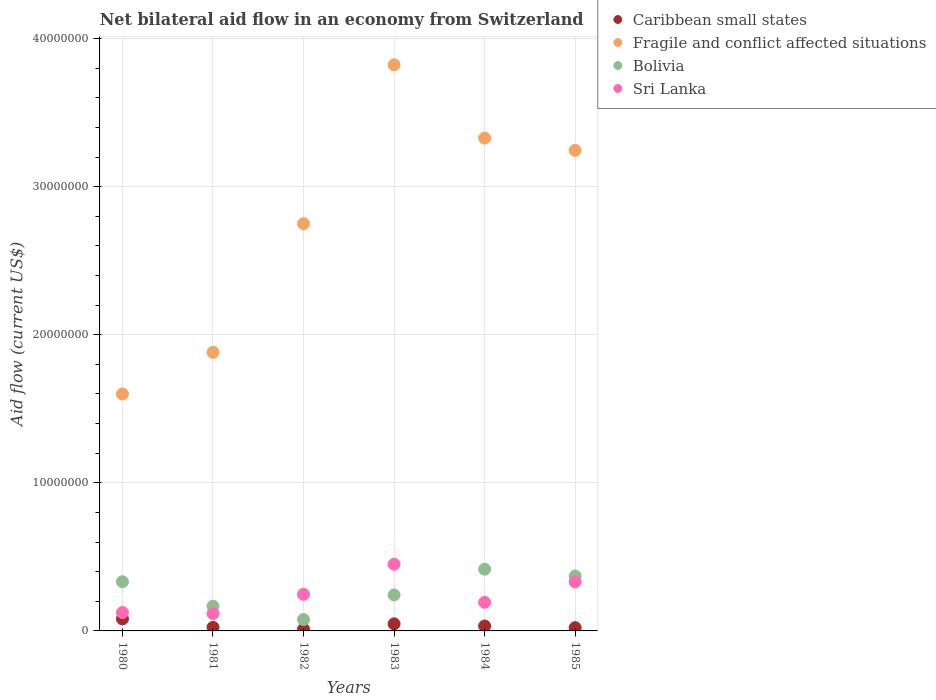How many different coloured dotlines are there?
Provide a succinct answer. 4. Is the number of dotlines equal to the number of legend labels?
Your answer should be very brief. Yes. What is the net bilateral aid flow in Fragile and conflict affected situations in 1985?
Offer a terse response. 3.24e+07. Across all years, what is the maximum net bilateral aid flow in Fragile and conflict affected situations?
Your answer should be compact. 3.82e+07. Across all years, what is the minimum net bilateral aid flow in Fragile and conflict affected situations?
Your answer should be very brief. 1.60e+07. In which year was the net bilateral aid flow in Fragile and conflict affected situations minimum?
Your answer should be compact. 1980. What is the total net bilateral aid flow in Sri Lanka in the graph?
Offer a very short reply. 1.46e+07. What is the difference between the net bilateral aid flow in Sri Lanka in 1981 and that in 1985?
Provide a succinct answer. -2.14e+06. What is the difference between the net bilateral aid flow in Caribbean small states in 1980 and the net bilateral aid flow in Bolivia in 1982?
Make the answer very short. 4.00e+04. What is the average net bilateral aid flow in Fragile and conflict affected situations per year?
Your answer should be very brief. 2.77e+07. In the year 1985, what is the difference between the net bilateral aid flow in Caribbean small states and net bilateral aid flow in Sri Lanka?
Keep it short and to the point. -3.09e+06. What is the ratio of the net bilateral aid flow in Sri Lanka in 1981 to that in 1983?
Your answer should be very brief. 0.26. Is the net bilateral aid flow in Caribbean small states in 1980 less than that in 1981?
Ensure brevity in your answer.  No. Is the difference between the net bilateral aid flow in Caribbean small states in 1982 and 1983 greater than the difference between the net bilateral aid flow in Sri Lanka in 1982 and 1983?
Ensure brevity in your answer.  Yes. What is the difference between the highest and the second highest net bilateral aid flow in Sri Lanka?
Ensure brevity in your answer.  1.19e+06. What is the difference between the highest and the lowest net bilateral aid flow in Sri Lanka?
Make the answer very short. 3.33e+06. In how many years, is the net bilateral aid flow in Caribbean small states greater than the average net bilateral aid flow in Caribbean small states taken over all years?
Give a very brief answer. 2. Is it the case that in every year, the sum of the net bilateral aid flow in Bolivia and net bilateral aid flow in Caribbean small states  is greater than the sum of net bilateral aid flow in Fragile and conflict affected situations and net bilateral aid flow in Sri Lanka?
Your response must be concise. No. Is it the case that in every year, the sum of the net bilateral aid flow in Fragile and conflict affected situations and net bilateral aid flow in Caribbean small states  is greater than the net bilateral aid flow in Sri Lanka?
Your answer should be compact. Yes. Is the net bilateral aid flow in Caribbean small states strictly less than the net bilateral aid flow in Bolivia over the years?
Offer a very short reply. Yes. Are the values on the major ticks of Y-axis written in scientific E-notation?
Your answer should be compact. No. Does the graph contain any zero values?
Your answer should be compact. No. Does the graph contain grids?
Ensure brevity in your answer.  Yes. How are the legend labels stacked?
Offer a terse response. Vertical. What is the title of the graph?
Offer a terse response. Net bilateral aid flow in an economy from Switzerland. What is the label or title of the Y-axis?
Your response must be concise. Aid flow (current US$). What is the Aid flow (current US$) in Caribbean small states in 1980?
Your answer should be very brief. 8.10e+05. What is the Aid flow (current US$) in Fragile and conflict affected situations in 1980?
Offer a very short reply. 1.60e+07. What is the Aid flow (current US$) of Bolivia in 1980?
Your answer should be very brief. 3.32e+06. What is the Aid flow (current US$) in Sri Lanka in 1980?
Give a very brief answer. 1.24e+06. What is the Aid flow (current US$) of Caribbean small states in 1981?
Provide a succinct answer. 2.40e+05. What is the Aid flow (current US$) of Fragile and conflict affected situations in 1981?
Make the answer very short. 1.88e+07. What is the Aid flow (current US$) in Bolivia in 1981?
Your response must be concise. 1.67e+06. What is the Aid flow (current US$) of Sri Lanka in 1981?
Give a very brief answer. 1.17e+06. What is the Aid flow (current US$) in Caribbean small states in 1982?
Offer a terse response. 1.20e+05. What is the Aid flow (current US$) of Fragile and conflict affected situations in 1982?
Keep it short and to the point. 2.75e+07. What is the Aid flow (current US$) of Bolivia in 1982?
Ensure brevity in your answer.  7.70e+05. What is the Aid flow (current US$) in Sri Lanka in 1982?
Provide a short and direct response. 2.47e+06. What is the Aid flow (current US$) in Fragile and conflict affected situations in 1983?
Give a very brief answer. 3.82e+07. What is the Aid flow (current US$) in Bolivia in 1983?
Your response must be concise. 2.43e+06. What is the Aid flow (current US$) in Sri Lanka in 1983?
Keep it short and to the point. 4.50e+06. What is the Aid flow (current US$) of Fragile and conflict affected situations in 1984?
Offer a very short reply. 3.33e+07. What is the Aid flow (current US$) of Bolivia in 1984?
Offer a terse response. 4.17e+06. What is the Aid flow (current US$) of Sri Lanka in 1984?
Offer a very short reply. 1.93e+06. What is the Aid flow (current US$) in Caribbean small states in 1985?
Your response must be concise. 2.20e+05. What is the Aid flow (current US$) in Fragile and conflict affected situations in 1985?
Your response must be concise. 3.24e+07. What is the Aid flow (current US$) of Bolivia in 1985?
Make the answer very short. 3.71e+06. What is the Aid flow (current US$) in Sri Lanka in 1985?
Your answer should be very brief. 3.31e+06. Across all years, what is the maximum Aid flow (current US$) in Caribbean small states?
Your response must be concise. 8.10e+05. Across all years, what is the maximum Aid flow (current US$) of Fragile and conflict affected situations?
Provide a short and direct response. 3.82e+07. Across all years, what is the maximum Aid flow (current US$) in Bolivia?
Provide a short and direct response. 4.17e+06. Across all years, what is the maximum Aid flow (current US$) in Sri Lanka?
Provide a short and direct response. 4.50e+06. Across all years, what is the minimum Aid flow (current US$) of Caribbean small states?
Give a very brief answer. 1.20e+05. Across all years, what is the minimum Aid flow (current US$) of Fragile and conflict affected situations?
Keep it short and to the point. 1.60e+07. Across all years, what is the minimum Aid flow (current US$) in Bolivia?
Your response must be concise. 7.70e+05. Across all years, what is the minimum Aid flow (current US$) of Sri Lanka?
Provide a short and direct response. 1.17e+06. What is the total Aid flow (current US$) in Caribbean small states in the graph?
Give a very brief answer. 2.20e+06. What is the total Aid flow (current US$) of Fragile and conflict affected situations in the graph?
Ensure brevity in your answer.  1.66e+08. What is the total Aid flow (current US$) of Bolivia in the graph?
Your answer should be very brief. 1.61e+07. What is the total Aid flow (current US$) in Sri Lanka in the graph?
Your answer should be very brief. 1.46e+07. What is the difference between the Aid flow (current US$) in Caribbean small states in 1980 and that in 1981?
Offer a terse response. 5.70e+05. What is the difference between the Aid flow (current US$) of Fragile and conflict affected situations in 1980 and that in 1981?
Your response must be concise. -2.81e+06. What is the difference between the Aid flow (current US$) of Bolivia in 1980 and that in 1981?
Offer a terse response. 1.65e+06. What is the difference between the Aid flow (current US$) in Caribbean small states in 1980 and that in 1982?
Ensure brevity in your answer.  6.90e+05. What is the difference between the Aid flow (current US$) of Fragile and conflict affected situations in 1980 and that in 1982?
Make the answer very short. -1.15e+07. What is the difference between the Aid flow (current US$) in Bolivia in 1980 and that in 1982?
Keep it short and to the point. 2.55e+06. What is the difference between the Aid flow (current US$) in Sri Lanka in 1980 and that in 1982?
Provide a short and direct response. -1.23e+06. What is the difference between the Aid flow (current US$) in Caribbean small states in 1980 and that in 1983?
Your response must be concise. 3.30e+05. What is the difference between the Aid flow (current US$) of Fragile and conflict affected situations in 1980 and that in 1983?
Provide a short and direct response. -2.22e+07. What is the difference between the Aid flow (current US$) in Bolivia in 1980 and that in 1983?
Offer a terse response. 8.90e+05. What is the difference between the Aid flow (current US$) in Sri Lanka in 1980 and that in 1983?
Provide a short and direct response. -3.26e+06. What is the difference between the Aid flow (current US$) of Caribbean small states in 1980 and that in 1984?
Your response must be concise. 4.80e+05. What is the difference between the Aid flow (current US$) in Fragile and conflict affected situations in 1980 and that in 1984?
Your answer should be compact. -1.73e+07. What is the difference between the Aid flow (current US$) of Bolivia in 1980 and that in 1984?
Make the answer very short. -8.50e+05. What is the difference between the Aid flow (current US$) in Sri Lanka in 1980 and that in 1984?
Ensure brevity in your answer.  -6.90e+05. What is the difference between the Aid flow (current US$) of Caribbean small states in 1980 and that in 1985?
Provide a succinct answer. 5.90e+05. What is the difference between the Aid flow (current US$) of Fragile and conflict affected situations in 1980 and that in 1985?
Offer a terse response. -1.64e+07. What is the difference between the Aid flow (current US$) in Bolivia in 1980 and that in 1985?
Keep it short and to the point. -3.90e+05. What is the difference between the Aid flow (current US$) of Sri Lanka in 1980 and that in 1985?
Provide a short and direct response. -2.07e+06. What is the difference between the Aid flow (current US$) of Caribbean small states in 1981 and that in 1982?
Provide a short and direct response. 1.20e+05. What is the difference between the Aid flow (current US$) in Fragile and conflict affected situations in 1981 and that in 1982?
Ensure brevity in your answer.  -8.69e+06. What is the difference between the Aid flow (current US$) in Sri Lanka in 1981 and that in 1982?
Make the answer very short. -1.30e+06. What is the difference between the Aid flow (current US$) of Caribbean small states in 1981 and that in 1983?
Your response must be concise. -2.40e+05. What is the difference between the Aid flow (current US$) in Fragile and conflict affected situations in 1981 and that in 1983?
Provide a short and direct response. -1.94e+07. What is the difference between the Aid flow (current US$) in Bolivia in 1981 and that in 1983?
Your answer should be compact. -7.60e+05. What is the difference between the Aid flow (current US$) of Sri Lanka in 1981 and that in 1983?
Your response must be concise. -3.33e+06. What is the difference between the Aid flow (current US$) of Fragile and conflict affected situations in 1981 and that in 1984?
Ensure brevity in your answer.  -1.45e+07. What is the difference between the Aid flow (current US$) of Bolivia in 1981 and that in 1984?
Offer a terse response. -2.50e+06. What is the difference between the Aid flow (current US$) of Sri Lanka in 1981 and that in 1984?
Offer a very short reply. -7.60e+05. What is the difference between the Aid flow (current US$) of Fragile and conflict affected situations in 1981 and that in 1985?
Provide a succinct answer. -1.36e+07. What is the difference between the Aid flow (current US$) of Bolivia in 1981 and that in 1985?
Provide a succinct answer. -2.04e+06. What is the difference between the Aid flow (current US$) in Sri Lanka in 1981 and that in 1985?
Ensure brevity in your answer.  -2.14e+06. What is the difference between the Aid flow (current US$) in Caribbean small states in 1982 and that in 1983?
Your response must be concise. -3.60e+05. What is the difference between the Aid flow (current US$) in Fragile and conflict affected situations in 1982 and that in 1983?
Ensure brevity in your answer.  -1.07e+07. What is the difference between the Aid flow (current US$) in Bolivia in 1982 and that in 1983?
Your answer should be compact. -1.66e+06. What is the difference between the Aid flow (current US$) in Sri Lanka in 1982 and that in 1983?
Your answer should be very brief. -2.03e+06. What is the difference between the Aid flow (current US$) in Fragile and conflict affected situations in 1982 and that in 1984?
Provide a short and direct response. -5.78e+06. What is the difference between the Aid flow (current US$) of Bolivia in 1982 and that in 1984?
Make the answer very short. -3.40e+06. What is the difference between the Aid flow (current US$) in Sri Lanka in 1982 and that in 1984?
Make the answer very short. 5.40e+05. What is the difference between the Aid flow (current US$) in Caribbean small states in 1982 and that in 1985?
Make the answer very short. -1.00e+05. What is the difference between the Aid flow (current US$) in Fragile and conflict affected situations in 1982 and that in 1985?
Give a very brief answer. -4.95e+06. What is the difference between the Aid flow (current US$) of Bolivia in 1982 and that in 1985?
Offer a very short reply. -2.94e+06. What is the difference between the Aid flow (current US$) in Sri Lanka in 1982 and that in 1985?
Keep it short and to the point. -8.40e+05. What is the difference between the Aid flow (current US$) of Fragile and conflict affected situations in 1983 and that in 1984?
Offer a terse response. 4.95e+06. What is the difference between the Aid flow (current US$) of Bolivia in 1983 and that in 1984?
Keep it short and to the point. -1.74e+06. What is the difference between the Aid flow (current US$) in Sri Lanka in 1983 and that in 1984?
Provide a succinct answer. 2.57e+06. What is the difference between the Aid flow (current US$) in Fragile and conflict affected situations in 1983 and that in 1985?
Offer a terse response. 5.78e+06. What is the difference between the Aid flow (current US$) in Bolivia in 1983 and that in 1985?
Ensure brevity in your answer.  -1.28e+06. What is the difference between the Aid flow (current US$) of Sri Lanka in 1983 and that in 1985?
Your answer should be very brief. 1.19e+06. What is the difference between the Aid flow (current US$) in Caribbean small states in 1984 and that in 1985?
Ensure brevity in your answer.  1.10e+05. What is the difference between the Aid flow (current US$) of Fragile and conflict affected situations in 1984 and that in 1985?
Your response must be concise. 8.30e+05. What is the difference between the Aid flow (current US$) of Sri Lanka in 1984 and that in 1985?
Give a very brief answer. -1.38e+06. What is the difference between the Aid flow (current US$) of Caribbean small states in 1980 and the Aid flow (current US$) of Fragile and conflict affected situations in 1981?
Provide a succinct answer. -1.80e+07. What is the difference between the Aid flow (current US$) in Caribbean small states in 1980 and the Aid flow (current US$) in Bolivia in 1981?
Give a very brief answer. -8.60e+05. What is the difference between the Aid flow (current US$) in Caribbean small states in 1980 and the Aid flow (current US$) in Sri Lanka in 1981?
Offer a terse response. -3.60e+05. What is the difference between the Aid flow (current US$) of Fragile and conflict affected situations in 1980 and the Aid flow (current US$) of Bolivia in 1981?
Your answer should be very brief. 1.43e+07. What is the difference between the Aid flow (current US$) of Fragile and conflict affected situations in 1980 and the Aid flow (current US$) of Sri Lanka in 1981?
Provide a short and direct response. 1.48e+07. What is the difference between the Aid flow (current US$) in Bolivia in 1980 and the Aid flow (current US$) in Sri Lanka in 1981?
Your answer should be very brief. 2.15e+06. What is the difference between the Aid flow (current US$) in Caribbean small states in 1980 and the Aid flow (current US$) in Fragile and conflict affected situations in 1982?
Your answer should be very brief. -2.67e+07. What is the difference between the Aid flow (current US$) in Caribbean small states in 1980 and the Aid flow (current US$) in Sri Lanka in 1982?
Provide a succinct answer. -1.66e+06. What is the difference between the Aid flow (current US$) in Fragile and conflict affected situations in 1980 and the Aid flow (current US$) in Bolivia in 1982?
Give a very brief answer. 1.52e+07. What is the difference between the Aid flow (current US$) of Fragile and conflict affected situations in 1980 and the Aid flow (current US$) of Sri Lanka in 1982?
Offer a very short reply. 1.35e+07. What is the difference between the Aid flow (current US$) of Bolivia in 1980 and the Aid flow (current US$) of Sri Lanka in 1982?
Your answer should be compact. 8.50e+05. What is the difference between the Aid flow (current US$) in Caribbean small states in 1980 and the Aid flow (current US$) in Fragile and conflict affected situations in 1983?
Your answer should be very brief. -3.74e+07. What is the difference between the Aid flow (current US$) of Caribbean small states in 1980 and the Aid flow (current US$) of Bolivia in 1983?
Give a very brief answer. -1.62e+06. What is the difference between the Aid flow (current US$) in Caribbean small states in 1980 and the Aid flow (current US$) in Sri Lanka in 1983?
Provide a short and direct response. -3.69e+06. What is the difference between the Aid flow (current US$) of Fragile and conflict affected situations in 1980 and the Aid flow (current US$) of Bolivia in 1983?
Make the answer very short. 1.36e+07. What is the difference between the Aid flow (current US$) in Fragile and conflict affected situations in 1980 and the Aid flow (current US$) in Sri Lanka in 1983?
Offer a terse response. 1.15e+07. What is the difference between the Aid flow (current US$) of Bolivia in 1980 and the Aid flow (current US$) of Sri Lanka in 1983?
Offer a terse response. -1.18e+06. What is the difference between the Aid flow (current US$) in Caribbean small states in 1980 and the Aid flow (current US$) in Fragile and conflict affected situations in 1984?
Make the answer very short. -3.25e+07. What is the difference between the Aid flow (current US$) in Caribbean small states in 1980 and the Aid flow (current US$) in Bolivia in 1984?
Your answer should be very brief. -3.36e+06. What is the difference between the Aid flow (current US$) in Caribbean small states in 1980 and the Aid flow (current US$) in Sri Lanka in 1984?
Your answer should be very brief. -1.12e+06. What is the difference between the Aid flow (current US$) in Fragile and conflict affected situations in 1980 and the Aid flow (current US$) in Bolivia in 1984?
Offer a terse response. 1.18e+07. What is the difference between the Aid flow (current US$) of Fragile and conflict affected situations in 1980 and the Aid flow (current US$) of Sri Lanka in 1984?
Your answer should be compact. 1.41e+07. What is the difference between the Aid flow (current US$) in Bolivia in 1980 and the Aid flow (current US$) in Sri Lanka in 1984?
Your answer should be compact. 1.39e+06. What is the difference between the Aid flow (current US$) in Caribbean small states in 1980 and the Aid flow (current US$) in Fragile and conflict affected situations in 1985?
Provide a short and direct response. -3.16e+07. What is the difference between the Aid flow (current US$) of Caribbean small states in 1980 and the Aid flow (current US$) of Bolivia in 1985?
Make the answer very short. -2.90e+06. What is the difference between the Aid flow (current US$) of Caribbean small states in 1980 and the Aid flow (current US$) of Sri Lanka in 1985?
Your answer should be very brief. -2.50e+06. What is the difference between the Aid flow (current US$) in Fragile and conflict affected situations in 1980 and the Aid flow (current US$) in Bolivia in 1985?
Your response must be concise. 1.23e+07. What is the difference between the Aid flow (current US$) in Fragile and conflict affected situations in 1980 and the Aid flow (current US$) in Sri Lanka in 1985?
Your answer should be very brief. 1.27e+07. What is the difference between the Aid flow (current US$) in Bolivia in 1980 and the Aid flow (current US$) in Sri Lanka in 1985?
Make the answer very short. 10000. What is the difference between the Aid flow (current US$) of Caribbean small states in 1981 and the Aid flow (current US$) of Fragile and conflict affected situations in 1982?
Your response must be concise. -2.73e+07. What is the difference between the Aid flow (current US$) of Caribbean small states in 1981 and the Aid flow (current US$) of Bolivia in 1982?
Offer a terse response. -5.30e+05. What is the difference between the Aid flow (current US$) of Caribbean small states in 1981 and the Aid flow (current US$) of Sri Lanka in 1982?
Your answer should be very brief. -2.23e+06. What is the difference between the Aid flow (current US$) of Fragile and conflict affected situations in 1981 and the Aid flow (current US$) of Bolivia in 1982?
Your answer should be compact. 1.80e+07. What is the difference between the Aid flow (current US$) in Fragile and conflict affected situations in 1981 and the Aid flow (current US$) in Sri Lanka in 1982?
Offer a very short reply. 1.63e+07. What is the difference between the Aid flow (current US$) of Bolivia in 1981 and the Aid flow (current US$) of Sri Lanka in 1982?
Provide a short and direct response. -8.00e+05. What is the difference between the Aid flow (current US$) of Caribbean small states in 1981 and the Aid flow (current US$) of Fragile and conflict affected situations in 1983?
Your answer should be compact. -3.80e+07. What is the difference between the Aid flow (current US$) in Caribbean small states in 1981 and the Aid flow (current US$) in Bolivia in 1983?
Ensure brevity in your answer.  -2.19e+06. What is the difference between the Aid flow (current US$) of Caribbean small states in 1981 and the Aid flow (current US$) of Sri Lanka in 1983?
Your answer should be very brief. -4.26e+06. What is the difference between the Aid flow (current US$) of Fragile and conflict affected situations in 1981 and the Aid flow (current US$) of Bolivia in 1983?
Give a very brief answer. 1.64e+07. What is the difference between the Aid flow (current US$) of Fragile and conflict affected situations in 1981 and the Aid flow (current US$) of Sri Lanka in 1983?
Your response must be concise. 1.43e+07. What is the difference between the Aid flow (current US$) in Bolivia in 1981 and the Aid flow (current US$) in Sri Lanka in 1983?
Provide a short and direct response. -2.83e+06. What is the difference between the Aid flow (current US$) in Caribbean small states in 1981 and the Aid flow (current US$) in Fragile and conflict affected situations in 1984?
Keep it short and to the point. -3.30e+07. What is the difference between the Aid flow (current US$) in Caribbean small states in 1981 and the Aid flow (current US$) in Bolivia in 1984?
Your answer should be compact. -3.93e+06. What is the difference between the Aid flow (current US$) of Caribbean small states in 1981 and the Aid flow (current US$) of Sri Lanka in 1984?
Offer a terse response. -1.69e+06. What is the difference between the Aid flow (current US$) of Fragile and conflict affected situations in 1981 and the Aid flow (current US$) of Bolivia in 1984?
Offer a very short reply. 1.46e+07. What is the difference between the Aid flow (current US$) of Fragile and conflict affected situations in 1981 and the Aid flow (current US$) of Sri Lanka in 1984?
Provide a short and direct response. 1.69e+07. What is the difference between the Aid flow (current US$) in Bolivia in 1981 and the Aid flow (current US$) in Sri Lanka in 1984?
Offer a terse response. -2.60e+05. What is the difference between the Aid flow (current US$) of Caribbean small states in 1981 and the Aid flow (current US$) of Fragile and conflict affected situations in 1985?
Provide a short and direct response. -3.22e+07. What is the difference between the Aid flow (current US$) of Caribbean small states in 1981 and the Aid flow (current US$) of Bolivia in 1985?
Make the answer very short. -3.47e+06. What is the difference between the Aid flow (current US$) of Caribbean small states in 1981 and the Aid flow (current US$) of Sri Lanka in 1985?
Offer a very short reply. -3.07e+06. What is the difference between the Aid flow (current US$) in Fragile and conflict affected situations in 1981 and the Aid flow (current US$) in Bolivia in 1985?
Provide a succinct answer. 1.51e+07. What is the difference between the Aid flow (current US$) of Fragile and conflict affected situations in 1981 and the Aid flow (current US$) of Sri Lanka in 1985?
Your answer should be compact. 1.55e+07. What is the difference between the Aid flow (current US$) in Bolivia in 1981 and the Aid flow (current US$) in Sri Lanka in 1985?
Your response must be concise. -1.64e+06. What is the difference between the Aid flow (current US$) in Caribbean small states in 1982 and the Aid flow (current US$) in Fragile and conflict affected situations in 1983?
Your response must be concise. -3.81e+07. What is the difference between the Aid flow (current US$) of Caribbean small states in 1982 and the Aid flow (current US$) of Bolivia in 1983?
Offer a very short reply. -2.31e+06. What is the difference between the Aid flow (current US$) of Caribbean small states in 1982 and the Aid flow (current US$) of Sri Lanka in 1983?
Ensure brevity in your answer.  -4.38e+06. What is the difference between the Aid flow (current US$) in Fragile and conflict affected situations in 1982 and the Aid flow (current US$) in Bolivia in 1983?
Keep it short and to the point. 2.51e+07. What is the difference between the Aid flow (current US$) of Fragile and conflict affected situations in 1982 and the Aid flow (current US$) of Sri Lanka in 1983?
Offer a very short reply. 2.30e+07. What is the difference between the Aid flow (current US$) in Bolivia in 1982 and the Aid flow (current US$) in Sri Lanka in 1983?
Offer a terse response. -3.73e+06. What is the difference between the Aid flow (current US$) in Caribbean small states in 1982 and the Aid flow (current US$) in Fragile and conflict affected situations in 1984?
Provide a succinct answer. -3.32e+07. What is the difference between the Aid flow (current US$) of Caribbean small states in 1982 and the Aid flow (current US$) of Bolivia in 1984?
Offer a terse response. -4.05e+06. What is the difference between the Aid flow (current US$) of Caribbean small states in 1982 and the Aid flow (current US$) of Sri Lanka in 1984?
Your answer should be very brief. -1.81e+06. What is the difference between the Aid flow (current US$) in Fragile and conflict affected situations in 1982 and the Aid flow (current US$) in Bolivia in 1984?
Ensure brevity in your answer.  2.33e+07. What is the difference between the Aid flow (current US$) in Fragile and conflict affected situations in 1982 and the Aid flow (current US$) in Sri Lanka in 1984?
Ensure brevity in your answer.  2.56e+07. What is the difference between the Aid flow (current US$) of Bolivia in 1982 and the Aid flow (current US$) of Sri Lanka in 1984?
Ensure brevity in your answer.  -1.16e+06. What is the difference between the Aid flow (current US$) of Caribbean small states in 1982 and the Aid flow (current US$) of Fragile and conflict affected situations in 1985?
Offer a very short reply. -3.23e+07. What is the difference between the Aid flow (current US$) of Caribbean small states in 1982 and the Aid flow (current US$) of Bolivia in 1985?
Keep it short and to the point. -3.59e+06. What is the difference between the Aid flow (current US$) in Caribbean small states in 1982 and the Aid flow (current US$) in Sri Lanka in 1985?
Ensure brevity in your answer.  -3.19e+06. What is the difference between the Aid flow (current US$) of Fragile and conflict affected situations in 1982 and the Aid flow (current US$) of Bolivia in 1985?
Your answer should be very brief. 2.38e+07. What is the difference between the Aid flow (current US$) in Fragile and conflict affected situations in 1982 and the Aid flow (current US$) in Sri Lanka in 1985?
Make the answer very short. 2.42e+07. What is the difference between the Aid flow (current US$) of Bolivia in 1982 and the Aid flow (current US$) of Sri Lanka in 1985?
Your answer should be compact. -2.54e+06. What is the difference between the Aid flow (current US$) of Caribbean small states in 1983 and the Aid flow (current US$) of Fragile and conflict affected situations in 1984?
Your answer should be very brief. -3.28e+07. What is the difference between the Aid flow (current US$) in Caribbean small states in 1983 and the Aid flow (current US$) in Bolivia in 1984?
Provide a succinct answer. -3.69e+06. What is the difference between the Aid flow (current US$) in Caribbean small states in 1983 and the Aid flow (current US$) in Sri Lanka in 1984?
Your response must be concise. -1.45e+06. What is the difference between the Aid flow (current US$) in Fragile and conflict affected situations in 1983 and the Aid flow (current US$) in Bolivia in 1984?
Provide a short and direct response. 3.41e+07. What is the difference between the Aid flow (current US$) of Fragile and conflict affected situations in 1983 and the Aid flow (current US$) of Sri Lanka in 1984?
Provide a short and direct response. 3.63e+07. What is the difference between the Aid flow (current US$) of Caribbean small states in 1983 and the Aid flow (current US$) of Fragile and conflict affected situations in 1985?
Provide a short and direct response. -3.20e+07. What is the difference between the Aid flow (current US$) of Caribbean small states in 1983 and the Aid flow (current US$) of Bolivia in 1985?
Provide a short and direct response. -3.23e+06. What is the difference between the Aid flow (current US$) in Caribbean small states in 1983 and the Aid flow (current US$) in Sri Lanka in 1985?
Your answer should be compact. -2.83e+06. What is the difference between the Aid flow (current US$) of Fragile and conflict affected situations in 1983 and the Aid flow (current US$) of Bolivia in 1985?
Your answer should be compact. 3.45e+07. What is the difference between the Aid flow (current US$) of Fragile and conflict affected situations in 1983 and the Aid flow (current US$) of Sri Lanka in 1985?
Give a very brief answer. 3.49e+07. What is the difference between the Aid flow (current US$) in Bolivia in 1983 and the Aid flow (current US$) in Sri Lanka in 1985?
Offer a very short reply. -8.80e+05. What is the difference between the Aid flow (current US$) of Caribbean small states in 1984 and the Aid flow (current US$) of Fragile and conflict affected situations in 1985?
Keep it short and to the point. -3.21e+07. What is the difference between the Aid flow (current US$) in Caribbean small states in 1984 and the Aid flow (current US$) in Bolivia in 1985?
Ensure brevity in your answer.  -3.38e+06. What is the difference between the Aid flow (current US$) in Caribbean small states in 1984 and the Aid flow (current US$) in Sri Lanka in 1985?
Your answer should be very brief. -2.98e+06. What is the difference between the Aid flow (current US$) of Fragile and conflict affected situations in 1984 and the Aid flow (current US$) of Bolivia in 1985?
Make the answer very short. 2.96e+07. What is the difference between the Aid flow (current US$) of Fragile and conflict affected situations in 1984 and the Aid flow (current US$) of Sri Lanka in 1985?
Keep it short and to the point. 3.00e+07. What is the difference between the Aid flow (current US$) in Bolivia in 1984 and the Aid flow (current US$) in Sri Lanka in 1985?
Provide a short and direct response. 8.60e+05. What is the average Aid flow (current US$) in Caribbean small states per year?
Ensure brevity in your answer.  3.67e+05. What is the average Aid flow (current US$) of Fragile and conflict affected situations per year?
Your answer should be very brief. 2.77e+07. What is the average Aid flow (current US$) in Bolivia per year?
Provide a succinct answer. 2.68e+06. What is the average Aid flow (current US$) of Sri Lanka per year?
Your answer should be very brief. 2.44e+06. In the year 1980, what is the difference between the Aid flow (current US$) in Caribbean small states and Aid flow (current US$) in Fragile and conflict affected situations?
Your answer should be compact. -1.52e+07. In the year 1980, what is the difference between the Aid flow (current US$) of Caribbean small states and Aid flow (current US$) of Bolivia?
Provide a succinct answer. -2.51e+06. In the year 1980, what is the difference between the Aid flow (current US$) of Caribbean small states and Aid flow (current US$) of Sri Lanka?
Your response must be concise. -4.30e+05. In the year 1980, what is the difference between the Aid flow (current US$) in Fragile and conflict affected situations and Aid flow (current US$) in Bolivia?
Provide a short and direct response. 1.27e+07. In the year 1980, what is the difference between the Aid flow (current US$) of Fragile and conflict affected situations and Aid flow (current US$) of Sri Lanka?
Provide a succinct answer. 1.48e+07. In the year 1980, what is the difference between the Aid flow (current US$) of Bolivia and Aid flow (current US$) of Sri Lanka?
Make the answer very short. 2.08e+06. In the year 1981, what is the difference between the Aid flow (current US$) in Caribbean small states and Aid flow (current US$) in Fragile and conflict affected situations?
Your answer should be compact. -1.86e+07. In the year 1981, what is the difference between the Aid flow (current US$) in Caribbean small states and Aid flow (current US$) in Bolivia?
Your answer should be compact. -1.43e+06. In the year 1981, what is the difference between the Aid flow (current US$) of Caribbean small states and Aid flow (current US$) of Sri Lanka?
Keep it short and to the point. -9.30e+05. In the year 1981, what is the difference between the Aid flow (current US$) of Fragile and conflict affected situations and Aid flow (current US$) of Bolivia?
Your answer should be compact. 1.71e+07. In the year 1981, what is the difference between the Aid flow (current US$) of Fragile and conflict affected situations and Aid flow (current US$) of Sri Lanka?
Your answer should be very brief. 1.76e+07. In the year 1981, what is the difference between the Aid flow (current US$) in Bolivia and Aid flow (current US$) in Sri Lanka?
Ensure brevity in your answer.  5.00e+05. In the year 1982, what is the difference between the Aid flow (current US$) in Caribbean small states and Aid flow (current US$) in Fragile and conflict affected situations?
Your answer should be very brief. -2.74e+07. In the year 1982, what is the difference between the Aid flow (current US$) of Caribbean small states and Aid flow (current US$) of Bolivia?
Make the answer very short. -6.50e+05. In the year 1982, what is the difference between the Aid flow (current US$) in Caribbean small states and Aid flow (current US$) in Sri Lanka?
Ensure brevity in your answer.  -2.35e+06. In the year 1982, what is the difference between the Aid flow (current US$) of Fragile and conflict affected situations and Aid flow (current US$) of Bolivia?
Your response must be concise. 2.67e+07. In the year 1982, what is the difference between the Aid flow (current US$) in Fragile and conflict affected situations and Aid flow (current US$) in Sri Lanka?
Offer a terse response. 2.50e+07. In the year 1982, what is the difference between the Aid flow (current US$) in Bolivia and Aid flow (current US$) in Sri Lanka?
Your response must be concise. -1.70e+06. In the year 1983, what is the difference between the Aid flow (current US$) of Caribbean small states and Aid flow (current US$) of Fragile and conflict affected situations?
Give a very brief answer. -3.78e+07. In the year 1983, what is the difference between the Aid flow (current US$) in Caribbean small states and Aid flow (current US$) in Bolivia?
Offer a terse response. -1.95e+06. In the year 1983, what is the difference between the Aid flow (current US$) in Caribbean small states and Aid flow (current US$) in Sri Lanka?
Offer a very short reply. -4.02e+06. In the year 1983, what is the difference between the Aid flow (current US$) of Fragile and conflict affected situations and Aid flow (current US$) of Bolivia?
Ensure brevity in your answer.  3.58e+07. In the year 1983, what is the difference between the Aid flow (current US$) of Fragile and conflict affected situations and Aid flow (current US$) of Sri Lanka?
Provide a short and direct response. 3.37e+07. In the year 1983, what is the difference between the Aid flow (current US$) of Bolivia and Aid flow (current US$) of Sri Lanka?
Give a very brief answer. -2.07e+06. In the year 1984, what is the difference between the Aid flow (current US$) in Caribbean small states and Aid flow (current US$) in Fragile and conflict affected situations?
Offer a very short reply. -3.30e+07. In the year 1984, what is the difference between the Aid flow (current US$) in Caribbean small states and Aid flow (current US$) in Bolivia?
Give a very brief answer. -3.84e+06. In the year 1984, what is the difference between the Aid flow (current US$) in Caribbean small states and Aid flow (current US$) in Sri Lanka?
Your answer should be very brief. -1.60e+06. In the year 1984, what is the difference between the Aid flow (current US$) in Fragile and conflict affected situations and Aid flow (current US$) in Bolivia?
Give a very brief answer. 2.91e+07. In the year 1984, what is the difference between the Aid flow (current US$) of Fragile and conflict affected situations and Aid flow (current US$) of Sri Lanka?
Provide a succinct answer. 3.14e+07. In the year 1984, what is the difference between the Aid flow (current US$) of Bolivia and Aid flow (current US$) of Sri Lanka?
Offer a very short reply. 2.24e+06. In the year 1985, what is the difference between the Aid flow (current US$) of Caribbean small states and Aid flow (current US$) of Fragile and conflict affected situations?
Provide a short and direct response. -3.22e+07. In the year 1985, what is the difference between the Aid flow (current US$) of Caribbean small states and Aid flow (current US$) of Bolivia?
Offer a terse response. -3.49e+06. In the year 1985, what is the difference between the Aid flow (current US$) of Caribbean small states and Aid flow (current US$) of Sri Lanka?
Provide a succinct answer. -3.09e+06. In the year 1985, what is the difference between the Aid flow (current US$) in Fragile and conflict affected situations and Aid flow (current US$) in Bolivia?
Your response must be concise. 2.87e+07. In the year 1985, what is the difference between the Aid flow (current US$) in Fragile and conflict affected situations and Aid flow (current US$) in Sri Lanka?
Provide a succinct answer. 2.91e+07. What is the ratio of the Aid flow (current US$) of Caribbean small states in 1980 to that in 1981?
Provide a succinct answer. 3.38. What is the ratio of the Aid flow (current US$) of Fragile and conflict affected situations in 1980 to that in 1981?
Make the answer very short. 0.85. What is the ratio of the Aid flow (current US$) of Bolivia in 1980 to that in 1981?
Offer a very short reply. 1.99. What is the ratio of the Aid flow (current US$) in Sri Lanka in 1980 to that in 1981?
Your answer should be very brief. 1.06. What is the ratio of the Aid flow (current US$) in Caribbean small states in 1980 to that in 1982?
Offer a very short reply. 6.75. What is the ratio of the Aid flow (current US$) of Fragile and conflict affected situations in 1980 to that in 1982?
Provide a short and direct response. 0.58. What is the ratio of the Aid flow (current US$) of Bolivia in 1980 to that in 1982?
Give a very brief answer. 4.31. What is the ratio of the Aid flow (current US$) of Sri Lanka in 1980 to that in 1982?
Offer a terse response. 0.5. What is the ratio of the Aid flow (current US$) of Caribbean small states in 1980 to that in 1983?
Offer a terse response. 1.69. What is the ratio of the Aid flow (current US$) in Fragile and conflict affected situations in 1980 to that in 1983?
Your response must be concise. 0.42. What is the ratio of the Aid flow (current US$) of Bolivia in 1980 to that in 1983?
Offer a very short reply. 1.37. What is the ratio of the Aid flow (current US$) of Sri Lanka in 1980 to that in 1983?
Offer a very short reply. 0.28. What is the ratio of the Aid flow (current US$) in Caribbean small states in 1980 to that in 1984?
Offer a terse response. 2.45. What is the ratio of the Aid flow (current US$) in Fragile and conflict affected situations in 1980 to that in 1984?
Your response must be concise. 0.48. What is the ratio of the Aid flow (current US$) in Bolivia in 1980 to that in 1984?
Your response must be concise. 0.8. What is the ratio of the Aid flow (current US$) of Sri Lanka in 1980 to that in 1984?
Keep it short and to the point. 0.64. What is the ratio of the Aid flow (current US$) of Caribbean small states in 1980 to that in 1985?
Your answer should be very brief. 3.68. What is the ratio of the Aid flow (current US$) in Fragile and conflict affected situations in 1980 to that in 1985?
Ensure brevity in your answer.  0.49. What is the ratio of the Aid flow (current US$) in Bolivia in 1980 to that in 1985?
Your answer should be very brief. 0.89. What is the ratio of the Aid flow (current US$) of Sri Lanka in 1980 to that in 1985?
Give a very brief answer. 0.37. What is the ratio of the Aid flow (current US$) in Fragile and conflict affected situations in 1981 to that in 1982?
Your response must be concise. 0.68. What is the ratio of the Aid flow (current US$) of Bolivia in 1981 to that in 1982?
Make the answer very short. 2.17. What is the ratio of the Aid flow (current US$) in Sri Lanka in 1981 to that in 1982?
Your response must be concise. 0.47. What is the ratio of the Aid flow (current US$) in Fragile and conflict affected situations in 1981 to that in 1983?
Make the answer very short. 0.49. What is the ratio of the Aid flow (current US$) in Bolivia in 1981 to that in 1983?
Ensure brevity in your answer.  0.69. What is the ratio of the Aid flow (current US$) of Sri Lanka in 1981 to that in 1983?
Give a very brief answer. 0.26. What is the ratio of the Aid flow (current US$) in Caribbean small states in 1981 to that in 1984?
Your answer should be very brief. 0.73. What is the ratio of the Aid flow (current US$) in Fragile and conflict affected situations in 1981 to that in 1984?
Provide a succinct answer. 0.57. What is the ratio of the Aid flow (current US$) of Bolivia in 1981 to that in 1984?
Give a very brief answer. 0.4. What is the ratio of the Aid flow (current US$) of Sri Lanka in 1981 to that in 1984?
Keep it short and to the point. 0.61. What is the ratio of the Aid flow (current US$) in Caribbean small states in 1981 to that in 1985?
Your answer should be compact. 1.09. What is the ratio of the Aid flow (current US$) of Fragile and conflict affected situations in 1981 to that in 1985?
Give a very brief answer. 0.58. What is the ratio of the Aid flow (current US$) of Bolivia in 1981 to that in 1985?
Offer a very short reply. 0.45. What is the ratio of the Aid flow (current US$) in Sri Lanka in 1981 to that in 1985?
Offer a terse response. 0.35. What is the ratio of the Aid flow (current US$) of Caribbean small states in 1982 to that in 1983?
Your answer should be very brief. 0.25. What is the ratio of the Aid flow (current US$) of Fragile and conflict affected situations in 1982 to that in 1983?
Ensure brevity in your answer.  0.72. What is the ratio of the Aid flow (current US$) in Bolivia in 1982 to that in 1983?
Keep it short and to the point. 0.32. What is the ratio of the Aid flow (current US$) of Sri Lanka in 1982 to that in 1983?
Your answer should be compact. 0.55. What is the ratio of the Aid flow (current US$) of Caribbean small states in 1982 to that in 1984?
Offer a terse response. 0.36. What is the ratio of the Aid flow (current US$) of Fragile and conflict affected situations in 1982 to that in 1984?
Provide a succinct answer. 0.83. What is the ratio of the Aid flow (current US$) of Bolivia in 1982 to that in 1984?
Make the answer very short. 0.18. What is the ratio of the Aid flow (current US$) in Sri Lanka in 1982 to that in 1984?
Keep it short and to the point. 1.28. What is the ratio of the Aid flow (current US$) of Caribbean small states in 1982 to that in 1985?
Ensure brevity in your answer.  0.55. What is the ratio of the Aid flow (current US$) in Fragile and conflict affected situations in 1982 to that in 1985?
Make the answer very short. 0.85. What is the ratio of the Aid flow (current US$) of Bolivia in 1982 to that in 1985?
Your answer should be compact. 0.21. What is the ratio of the Aid flow (current US$) of Sri Lanka in 1982 to that in 1985?
Provide a short and direct response. 0.75. What is the ratio of the Aid flow (current US$) of Caribbean small states in 1983 to that in 1984?
Offer a terse response. 1.45. What is the ratio of the Aid flow (current US$) of Fragile and conflict affected situations in 1983 to that in 1984?
Offer a very short reply. 1.15. What is the ratio of the Aid flow (current US$) of Bolivia in 1983 to that in 1984?
Keep it short and to the point. 0.58. What is the ratio of the Aid flow (current US$) in Sri Lanka in 1983 to that in 1984?
Provide a short and direct response. 2.33. What is the ratio of the Aid flow (current US$) of Caribbean small states in 1983 to that in 1985?
Your answer should be very brief. 2.18. What is the ratio of the Aid flow (current US$) in Fragile and conflict affected situations in 1983 to that in 1985?
Give a very brief answer. 1.18. What is the ratio of the Aid flow (current US$) in Bolivia in 1983 to that in 1985?
Ensure brevity in your answer.  0.66. What is the ratio of the Aid flow (current US$) of Sri Lanka in 1983 to that in 1985?
Give a very brief answer. 1.36. What is the ratio of the Aid flow (current US$) in Fragile and conflict affected situations in 1984 to that in 1985?
Give a very brief answer. 1.03. What is the ratio of the Aid flow (current US$) of Bolivia in 1984 to that in 1985?
Provide a succinct answer. 1.12. What is the ratio of the Aid flow (current US$) of Sri Lanka in 1984 to that in 1985?
Offer a very short reply. 0.58. What is the difference between the highest and the second highest Aid flow (current US$) of Fragile and conflict affected situations?
Offer a terse response. 4.95e+06. What is the difference between the highest and the second highest Aid flow (current US$) in Sri Lanka?
Give a very brief answer. 1.19e+06. What is the difference between the highest and the lowest Aid flow (current US$) in Caribbean small states?
Give a very brief answer. 6.90e+05. What is the difference between the highest and the lowest Aid flow (current US$) of Fragile and conflict affected situations?
Your answer should be compact. 2.22e+07. What is the difference between the highest and the lowest Aid flow (current US$) in Bolivia?
Give a very brief answer. 3.40e+06. What is the difference between the highest and the lowest Aid flow (current US$) of Sri Lanka?
Provide a short and direct response. 3.33e+06. 